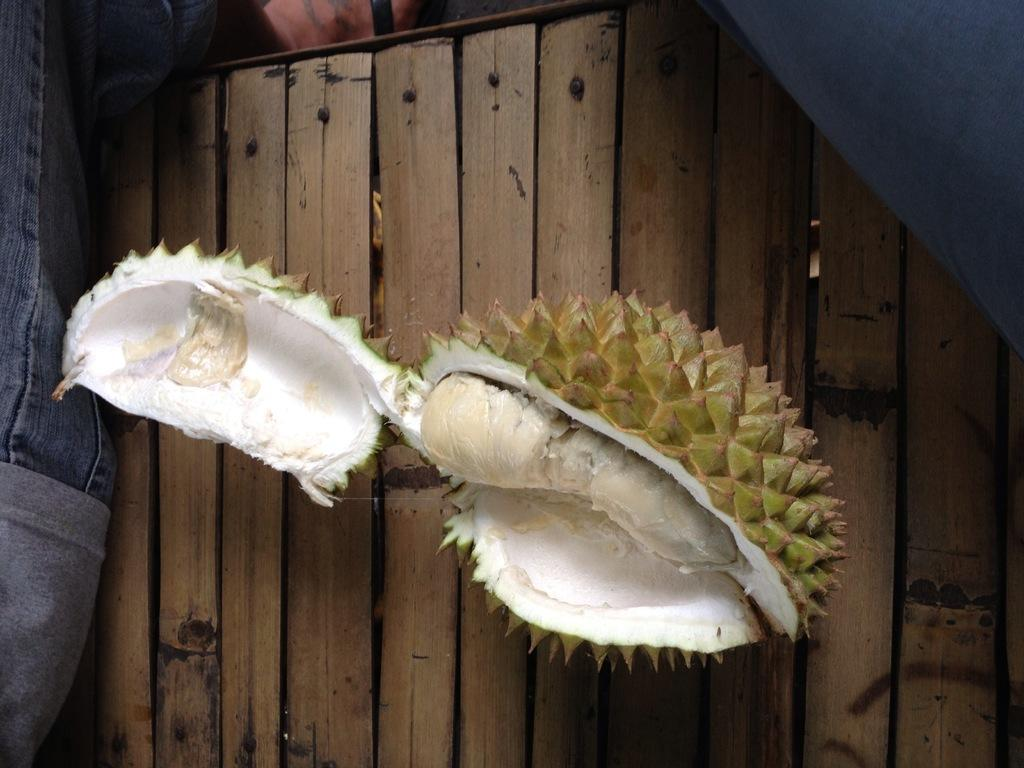What is the main subject in the center of the image? There is a durian fruit in the center of the image. Can you describe the person in the image? There is a person in the left corner of the image. What can be seen in the background of the image? There is a wall in the background of the image. What type of destruction can be seen in the image? There is no destruction present in the image; it features a durian fruit, a person, and a wall in the background. Can you tell me how many chickens are in the image? There are no chickens present in the image. 